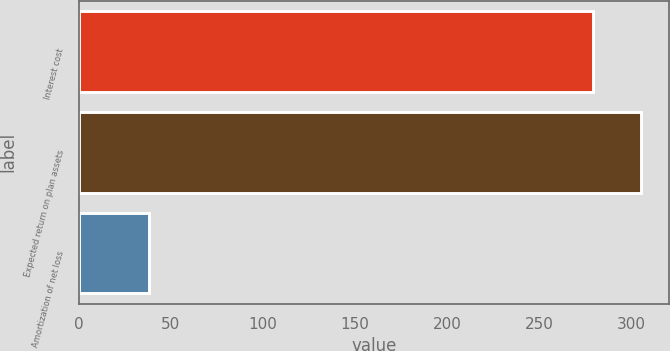Convert chart to OTSL. <chart><loc_0><loc_0><loc_500><loc_500><bar_chart><fcel>Interest cost<fcel>Expected return on plan assets<fcel>Amortization of net loss<nl><fcel>279<fcel>305<fcel>38<nl></chart> 